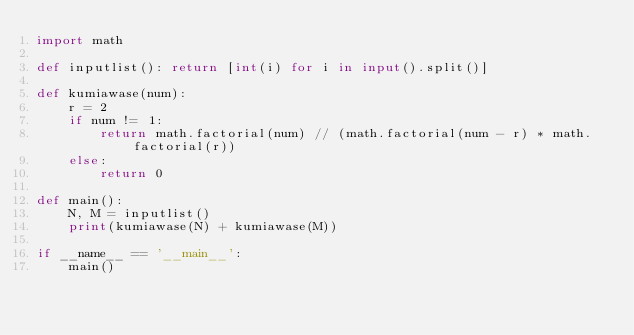Convert code to text. <code><loc_0><loc_0><loc_500><loc_500><_Python_>import math

def inputlist(): return [int(i) for i in input().split()]

def kumiawase(num):
    r = 2
    if num != 1:
        return math.factorial(num) // (math.factorial(num - r) * math.factorial(r))
    else:
        return 0

def main():
    N, M = inputlist()
    print(kumiawase(N) + kumiawase(M))

if __name__ == '__main__':
    main()</code> 